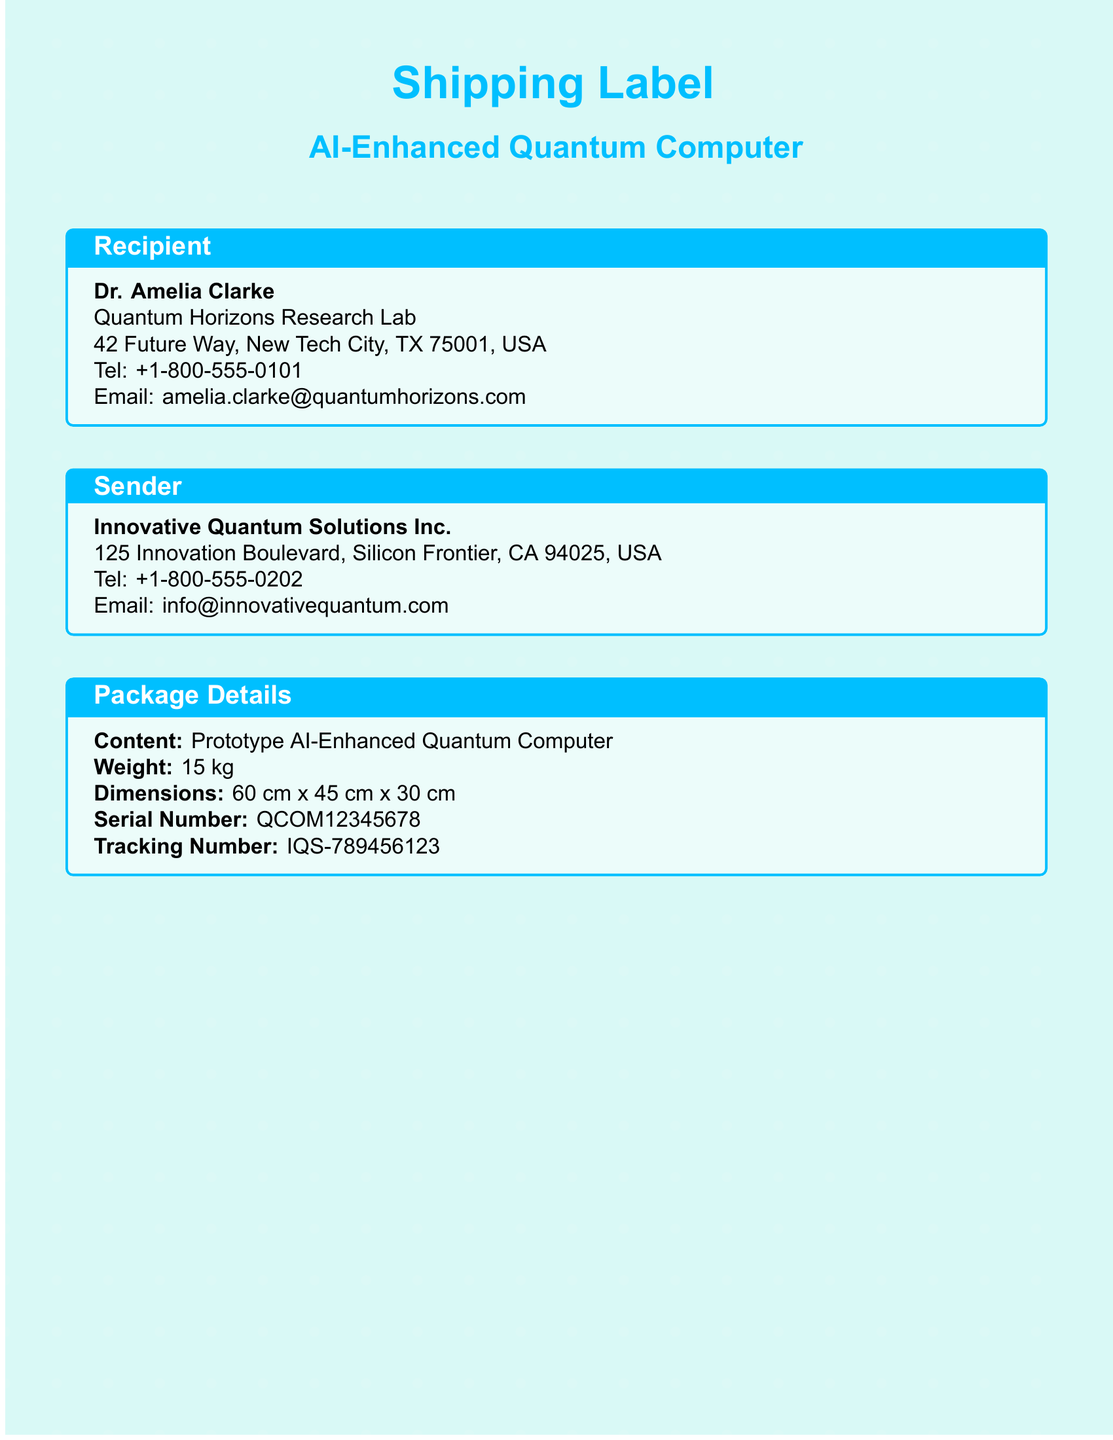what is the recipient's name? The recipient's name is listed in the 'Recipient' section of the document.
Answer: Dr. Amelia Clarke what is the weight of the package? The weight is specified in the 'Package Details' section.
Answer: 15 kg what is the serial number of the AI-enhanced quantum computer? The serial number is provided under 'Package Details'.
Answer: QCOM12345678 what is the expected delivery date? The expected delivery date is found in the 'Shipping Details' section.
Answer: 2023-12-20 how much is the insurance value of the package? The insurance value is mentioned in the 'Shipping Details'.
Answer: $2,000,000 what should be done to activate the holographic interface? This information can be found in the 'Holographic Instructions' section.
Answer: Pressing the power button what is the priority level of the shipment? The priority level is stated in the 'Shipping Details' section.
Answer: High why is it important to use anti-static gloves? This information can be inferred from the safety instructions in the document.
Answer: To handle the device safely what is the main purpose of the holographic guide? This is indicated in the 'Holographic Instructions' section for setup assistance.
Answer: To unpack and install safely 